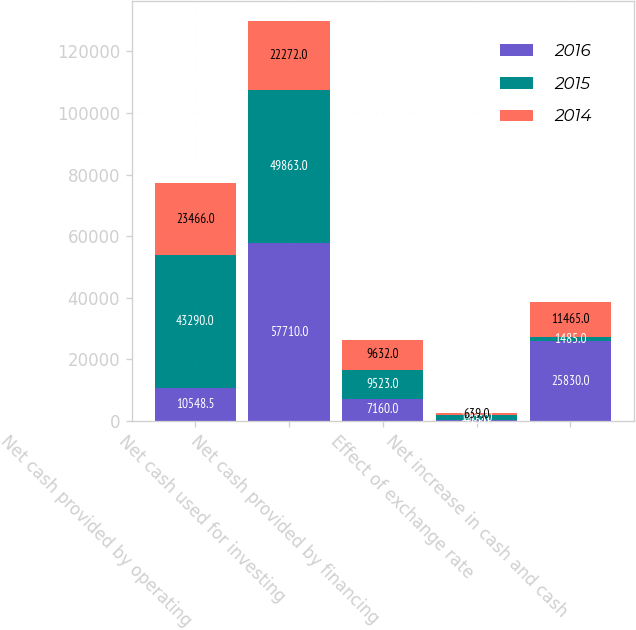Convert chart. <chart><loc_0><loc_0><loc_500><loc_500><stacked_bar_chart><ecel><fcel>Net cash provided by operating<fcel>Net cash used for investing<fcel>Net cash provided by financing<fcel>Effect of exchange rate<fcel>Net increase in cash and cash<nl><fcel>2016<fcel>10548.5<fcel>57710<fcel>7160<fcel>415<fcel>25830<nl><fcel>2015<fcel>43290<fcel>49863<fcel>9523<fcel>1465<fcel>1485<nl><fcel>2014<fcel>23466<fcel>22272<fcel>9632<fcel>639<fcel>11465<nl></chart> 